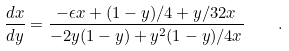Convert formula to latex. <formula><loc_0><loc_0><loc_500><loc_500>\frac { d x } { d y } = \frac { - \epsilon x + ( 1 - y ) / 4 + y / 3 2 x } { - 2 y ( 1 - y ) + y ^ { 2 } ( 1 - y ) / 4 x } \quad .</formula> 